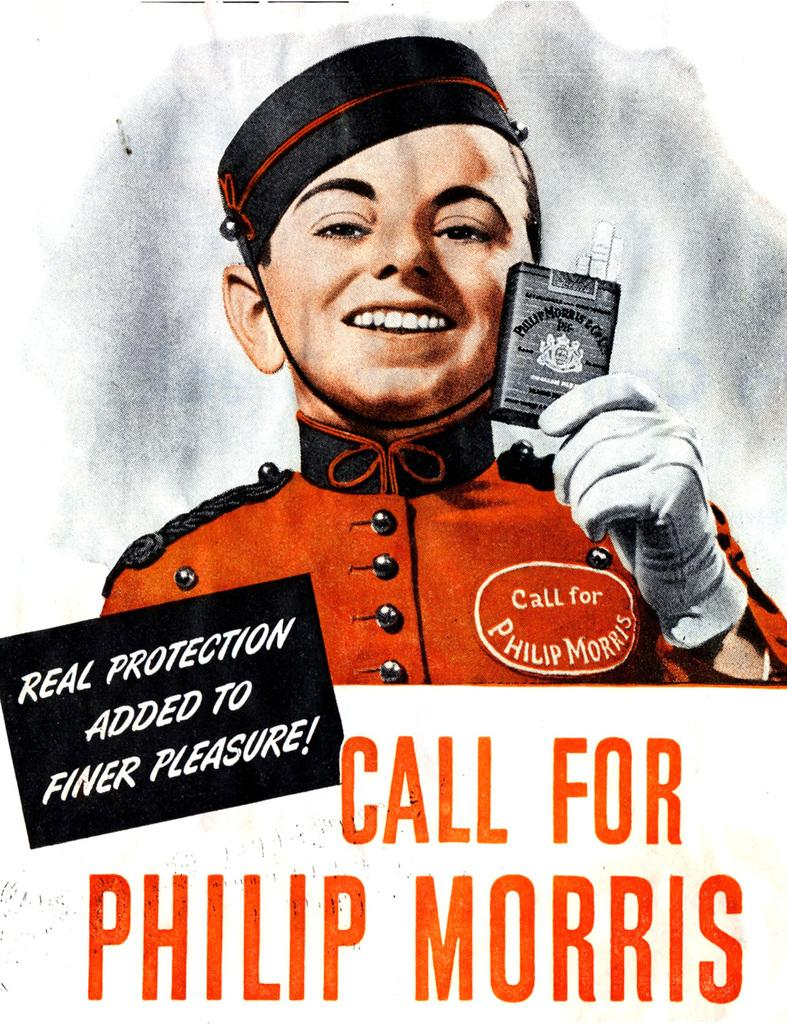What type of visual is depicted in the image? The image is a poster. Who or what is featured on the poster? There is a person in the poster. What accessories is the person wearing? The person is wearing a cap and gloves. What is the person holding in the poster? The person is holding something. What additional information is provided on the poster? There is text written on the poster. How many kittens are sitting on the person's shoe in the image? There are no kittens or shoes present in the image; it features a person wearing a cap and gloves and holding something. 